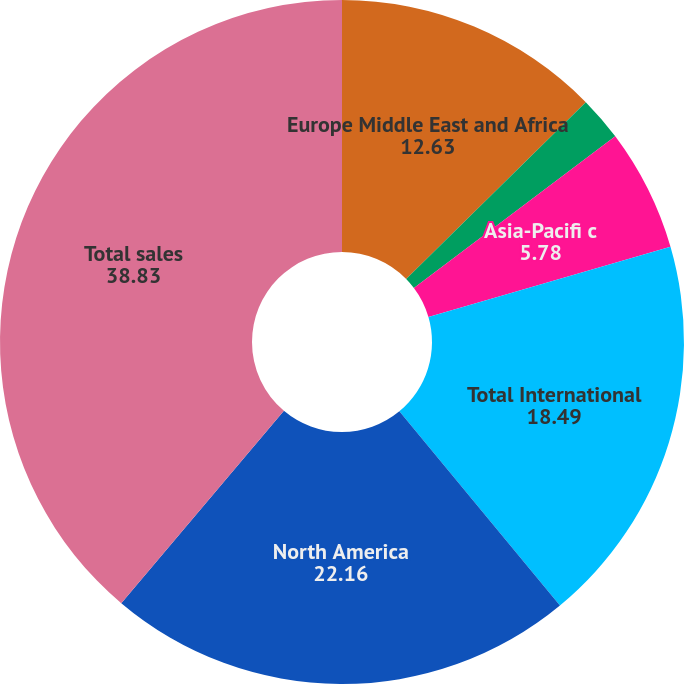<chart> <loc_0><loc_0><loc_500><loc_500><pie_chart><fcel>Europe Middle East and Africa<fcel>Latin America<fcel>Asia-Pacifi c<fcel>Total International<fcel>North America<fcel>Total sales<nl><fcel>12.63%<fcel>2.1%<fcel>5.78%<fcel>18.49%<fcel>22.16%<fcel>38.83%<nl></chart> 